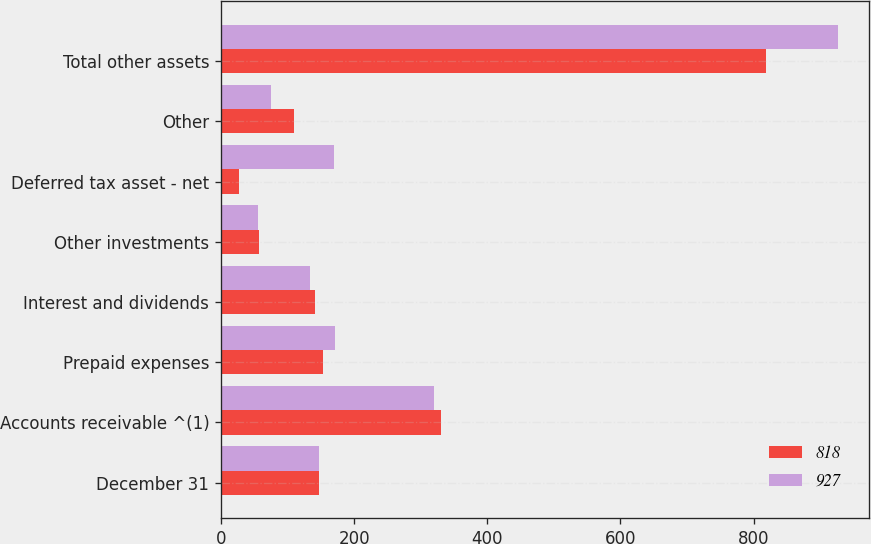<chart> <loc_0><loc_0><loc_500><loc_500><stacked_bar_chart><ecel><fcel>December 31<fcel>Accounts receivable ^(1)<fcel>Prepaid expenses<fcel>Interest and dividends<fcel>Other investments<fcel>Deferred tax asset - net<fcel>Other<fcel>Total other assets<nl><fcel>818<fcel>147.5<fcel>330<fcel>153<fcel>142<fcel>57<fcel>27<fcel>109<fcel>818<nl><fcel>927<fcel>147.5<fcel>320<fcel>172<fcel>134<fcel>56<fcel>170<fcel>75<fcel>927<nl></chart> 